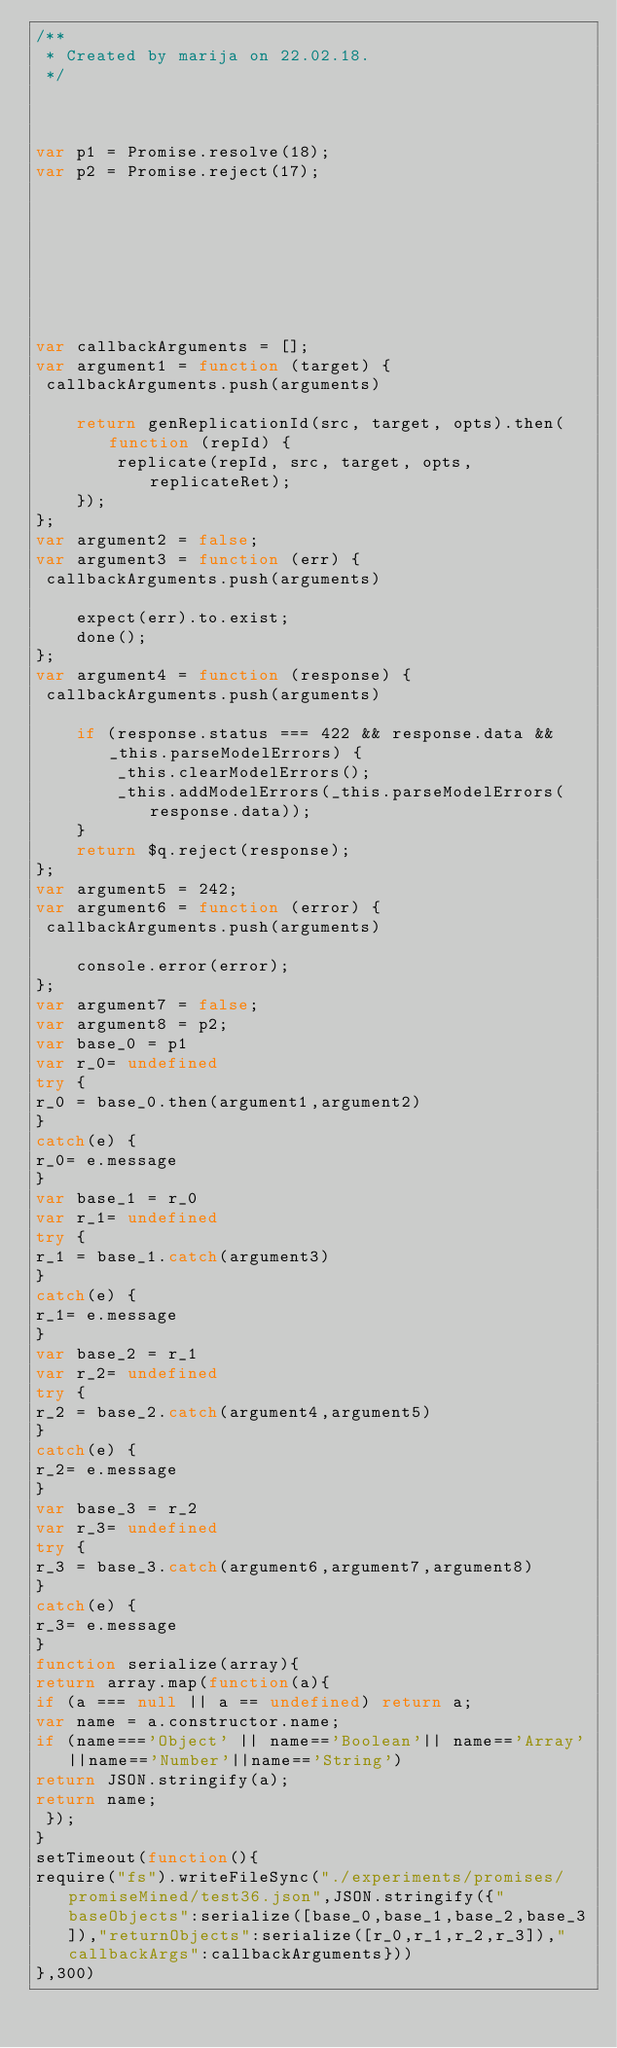Convert code to text. <code><loc_0><loc_0><loc_500><loc_500><_JavaScript_>/**
 * Created by marija on 22.02.18.
 */



var p1 = Promise.resolve(18);
var p2 = Promise.reject(17);








var callbackArguments = [];
var argument1 = function (target) {
 callbackArguments.push(arguments) 

    return genReplicationId(src, target, opts).then(function (repId) {
        replicate(repId, src, target, opts, replicateRet);
    });
};
var argument2 = false;
var argument3 = function (err) {
 callbackArguments.push(arguments) 

    expect(err).to.exist;
    done();
};
var argument4 = function (response) {
 callbackArguments.push(arguments) 

    if (response.status === 422 && response.data && _this.parseModelErrors) {
        _this.clearModelErrors();
        _this.addModelErrors(_this.parseModelErrors(response.data));
    }
    return $q.reject(response);
};
var argument5 = 242;
var argument6 = function (error) {
 callbackArguments.push(arguments) 

    console.error(error);
};
var argument7 = false;
var argument8 = p2;
var base_0 = p1
var r_0= undefined
try {
r_0 = base_0.then(argument1,argument2)
}
catch(e) {
r_0= e.message
}
var base_1 = r_0
var r_1= undefined
try {
r_1 = base_1.catch(argument3)
}
catch(e) {
r_1= e.message
}
var base_2 = r_1
var r_2= undefined
try {
r_2 = base_2.catch(argument4,argument5)
}
catch(e) {
r_2= e.message
}
var base_3 = r_2
var r_3= undefined
try {
r_3 = base_3.catch(argument6,argument7,argument8)
}
catch(e) {
r_3= e.message
}
function serialize(array){
return array.map(function(a){
if (a === null || a == undefined) return a;
var name = a.constructor.name;
if (name==='Object' || name=='Boolean'|| name=='Array'||name=='Number'||name=='String')
return JSON.stringify(a);
return name;
 });
}
setTimeout(function(){
require("fs").writeFileSync("./experiments/promises/promiseMined/test36.json",JSON.stringify({"baseObjects":serialize([base_0,base_1,base_2,base_3]),"returnObjects":serialize([r_0,r_1,r_2,r_3]),"callbackArgs":callbackArguments}))
},300)</code> 